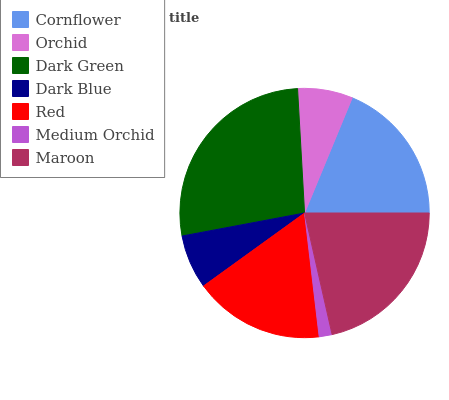Is Medium Orchid the minimum?
Answer yes or no. Yes. Is Dark Green the maximum?
Answer yes or no. Yes. Is Orchid the minimum?
Answer yes or no. No. Is Orchid the maximum?
Answer yes or no. No. Is Cornflower greater than Orchid?
Answer yes or no. Yes. Is Orchid less than Cornflower?
Answer yes or no. Yes. Is Orchid greater than Cornflower?
Answer yes or no. No. Is Cornflower less than Orchid?
Answer yes or no. No. Is Red the high median?
Answer yes or no. Yes. Is Red the low median?
Answer yes or no. Yes. Is Dark Blue the high median?
Answer yes or no. No. Is Medium Orchid the low median?
Answer yes or no. No. 